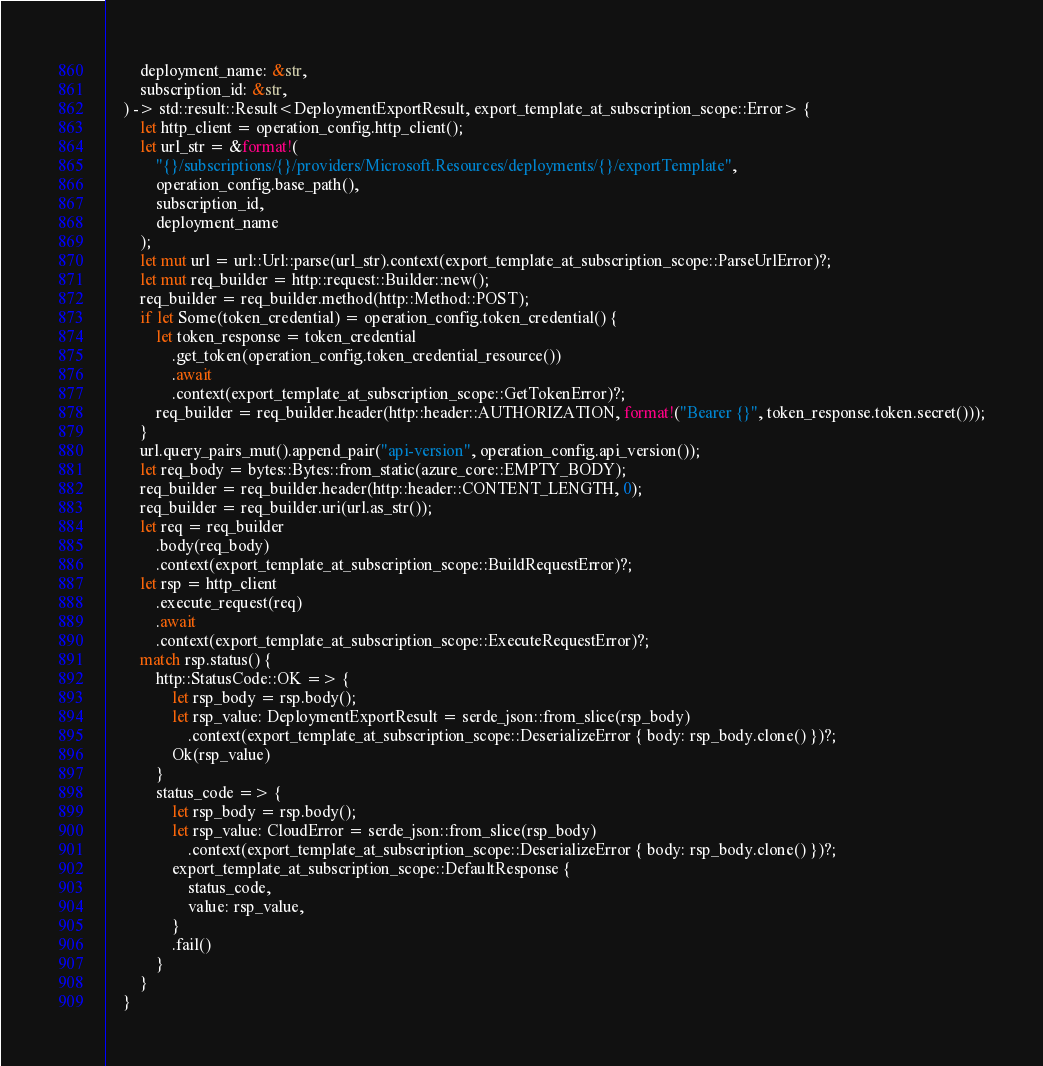Convert code to text. <code><loc_0><loc_0><loc_500><loc_500><_Rust_>        deployment_name: &str,
        subscription_id: &str,
    ) -> std::result::Result<DeploymentExportResult, export_template_at_subscription_scope::Error> {
        let http_client = operation_config.http_client();
        let url_str = &format!(
            "{}/subscriptions/{}/providers/Microsoft.Resources/deployments/{}/exportTemplate",
            operation_config.base_path(),
            subscription_id,
            deployment_name
        );
        let mut url = url::Url::parse(url_str).context(export_template_at_subscription_scope::ParseUrlError)?;
        let mut req_builder = http::request::Builder::new();
        req_builder = req_builder.method(http::Method::POST);
        if let Some(token_credential) = operation_config.token_credential() {
            let token_response = token_credential
                .get_token(operation_config.token_credential_resource())
                .await
                .context(export_template_at_subscription_scope::GetTokenError)?;
            req_builder = req_builder.header(http::header::AUTHORIZATION, format!("Bearer {}", token_response.token.secret()));
        }
        url.query_pairs_mut().append_pair("api-version", operation_config.api_version());
        let req_body = bytes::Bytes::from_static(azure_core::EMPTY_BODY);
        req_builder = req_builder.header(http::header::CONTENT_LENGTH, 0);
        req_builder = req_builder.uri(url.as_str());
        let req = req_builder
            .body(req_body)
            .context(export_template_at_subscription_scope::BuildRequestError)?;
        let rsp = http_client
            .execute_request(req)
            .await
            .context(export_template_at_subscription_scope::ExecuteRequestError)?;
        match rsp.status() {
            http::StatusCode::OK => {
                let rsp_body = rsp.body();
                let rsp_value: DeploymentExportResult = serde_json::from_slice(rsp_body)
                    .context(export_template_at_subscription_scope::DeserializeError { body: rsp_body.clone() })?;
                Ok(rsp_value)
            }
            status_code => {
                let rsp_body = rsp.body();
                let rsp_value: CloudError = serde_json::from_slice(rsp_body)
                    .context(export_template_at_subscription_scope::DeserializeError { body: rsp_body.clone() })?;
                export_template_at_subscription_scope::DefaultResponse {
                    status_code,
                    value: rsp_value,
                }
                .fail()
            }
        }
    }</code> 